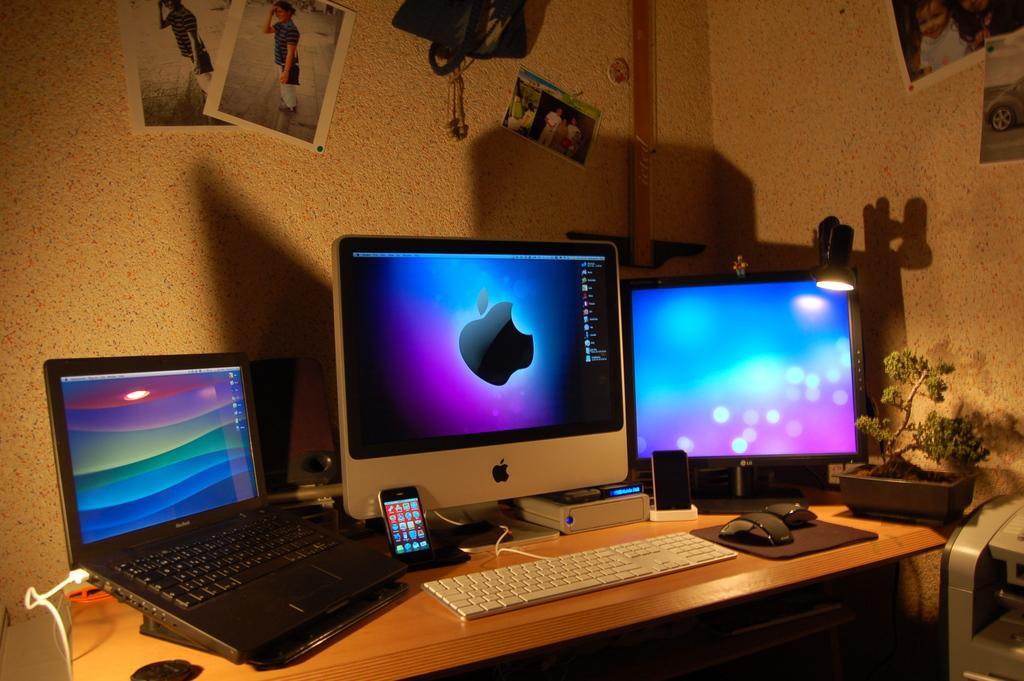Describe this image in one or two sentences. This is a room at the corner on the table there is a laptop,mobile phone,2 PC's,keyboard,mouse and a water plant. On the wall there are photographs attached to it and a poster. 